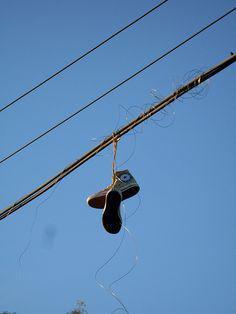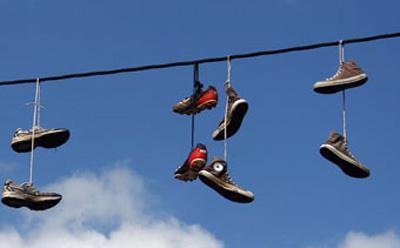The first image is the image on the left, the second image is the image on the right. For the images shown, is this caption "There are no more than 2 pairs of shoes hanging from a power line." true? Answer yes or no. No. The first image is the image on the left, the second image is the image on the right. Assess this claim about the two images: "Multiple pairs of shoes are hanging from the power lines in at least one picture.". Correct or not? Answer yes or no. Yes. 